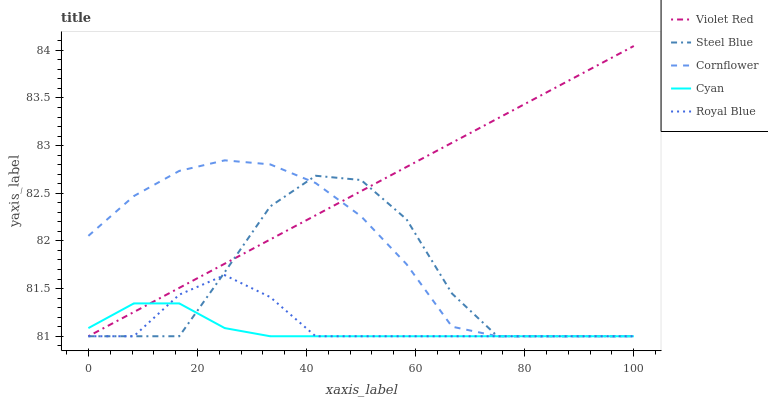Does Steel Blue have the minimum area under the curve?
Answer yes or no. No. Does Steel Blue have the maximum area under the curve?
Answer yes or no. No. Is Steel Blue the smoothest?
Answer yes or no. No. Is Violet Red the roughest?
Answer yes or no. No. Does Steel Blue have the highest value?
Answer yes or no. No. 